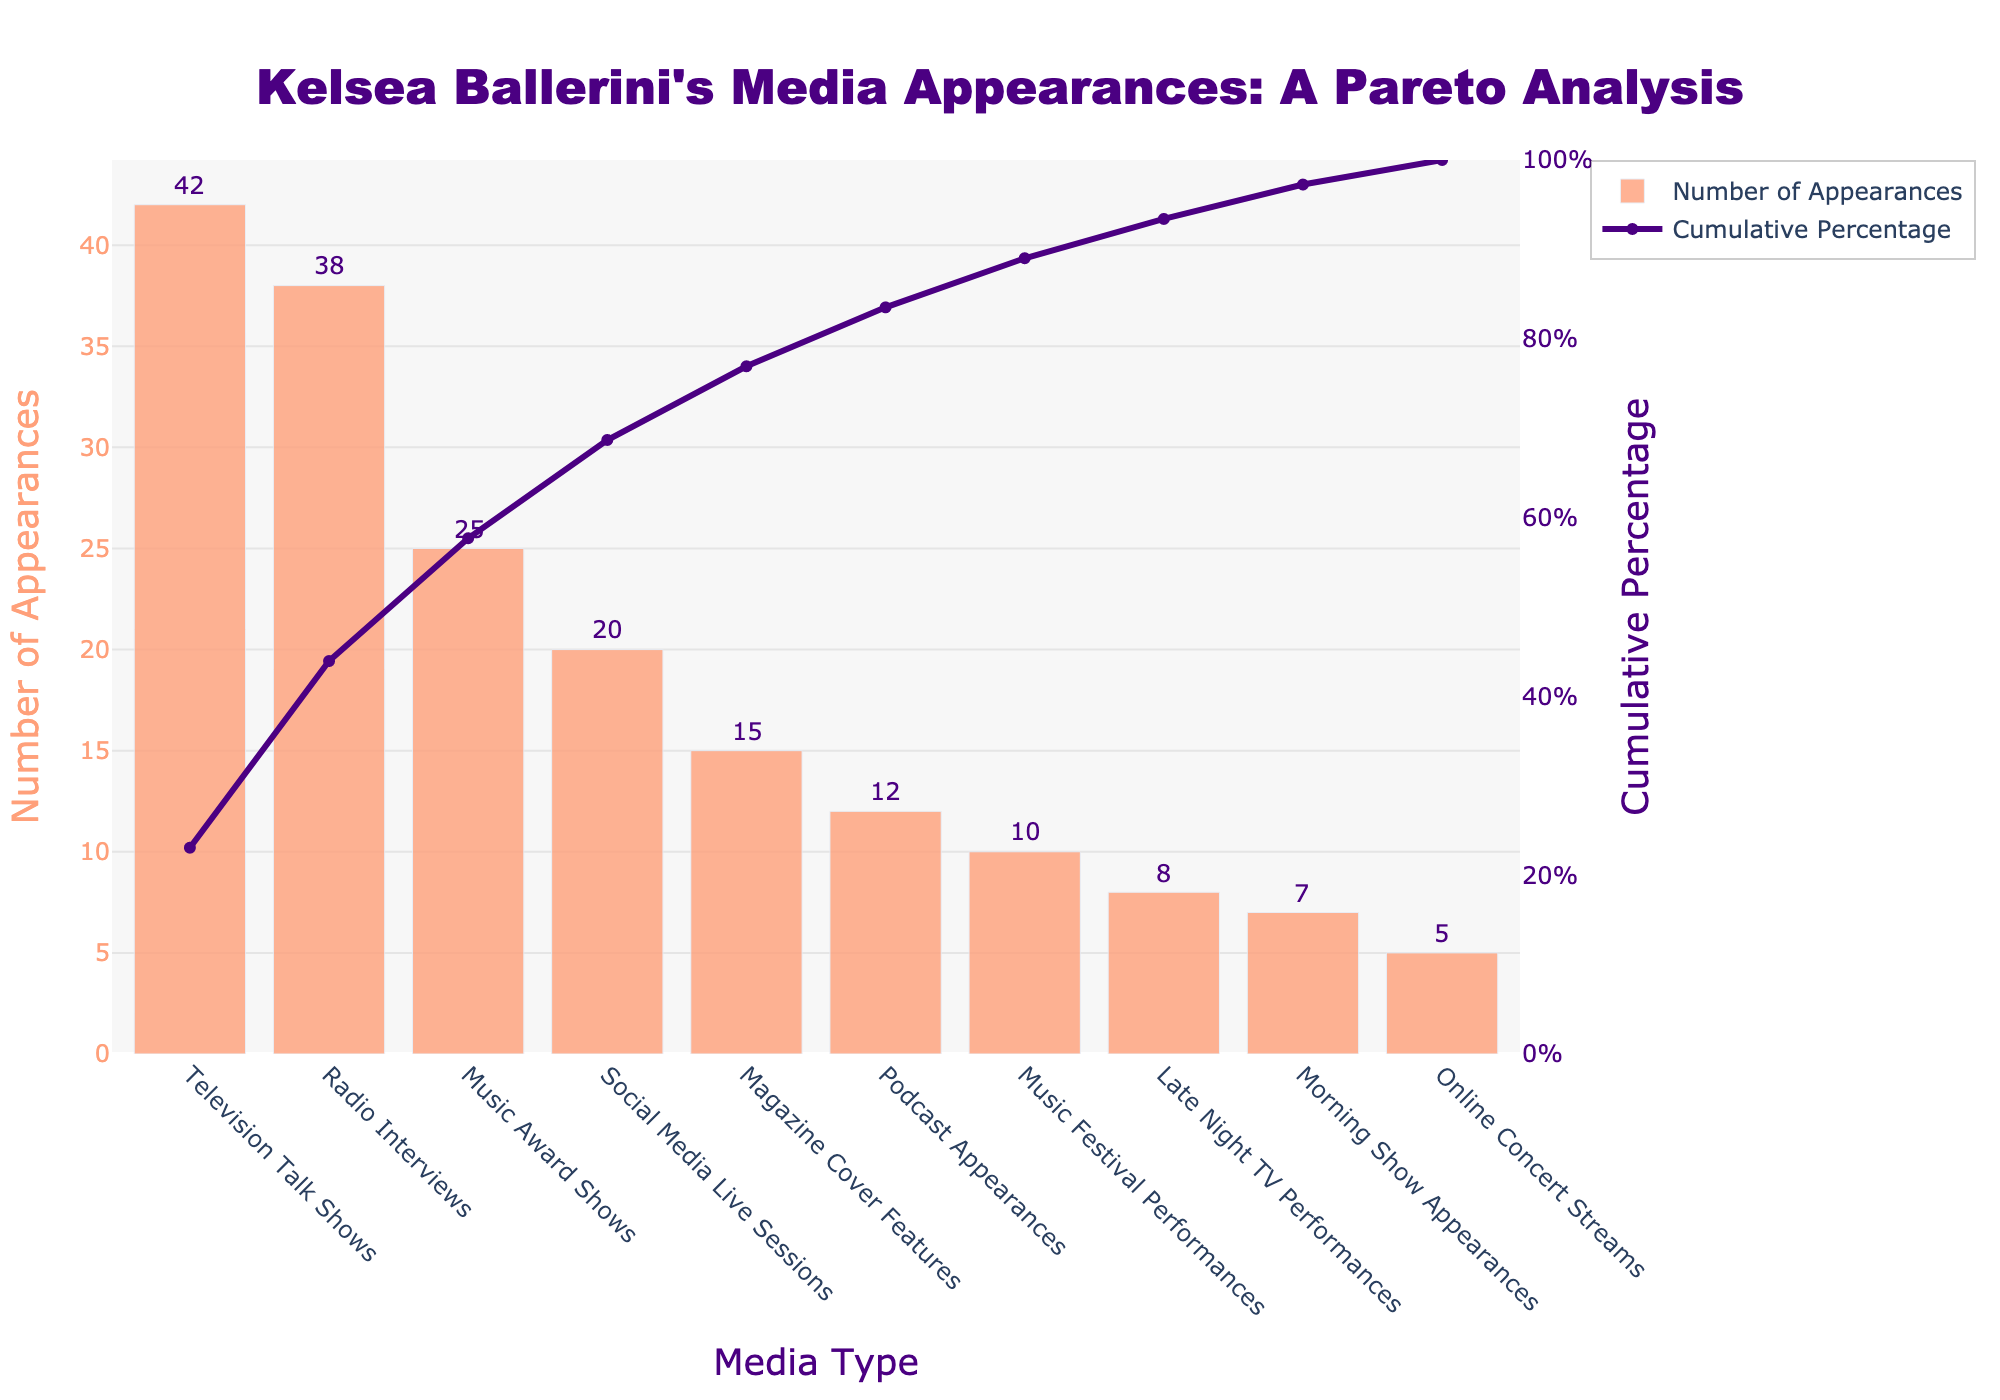How many types of media does Kelsea Ballerini use for her promotions? The x-axis of the figure lists the different media types used by Kelsea Ballerini for her promotions. Counting these types will give the total number.
Answer: 10 Which media type has the highest number of appearances? By observing the highest bar on the chart and reading the label on the x-axis, you determine the media type with the most appearances.
Answer: Television Talk Shows What is the total number of appearances made by Kelsea Ballerini across all media types? To find the sum of appearances for all media, add the number of appearances for each type. The numbers in the chart are: 42 (Television Talk Shows) + 38 (Radio Interviews) + 25 (Music Award Shows) + 20 (Social Media Live Sessions) + 15 (Magazine Cover Features) + 12 (Podcasts Appearances) + 10 (Music Festival Performances) + 8 (Late Night TV Performances) + 7 (Morning Show Appearances) + 5 (Online Concert Streams). Adding these: 42 + 38 + 25 + 20 + 15 + 12 + 10 + 8 + 7 + 5 = 182
Answer: 182 What percentage of total appearances do Television Talk Shows and Radio Interviews account for? First, add the number of appearances for the top two media types: 42 + 38 = 80. To find the percentage, divide by the total number of appearances and multiply by 100: (80 / 182) * 100 ≈ 43.96%.
Answer: ~43.96% At which cumulative percentage does the top three media types together reach? The cumulation of the first three media types from the top of the y-axis is 42 (Television Talk Shows) + 38 (Radio Interviews) + 25 (Music Award Shows) = 105. Next, calculate the cumulative percentage by (105 / 182) * 100 ≈ 57.69%.
Answer: ~57.69% Which media types have the least number of appearances, and what is their combined count? Observe the shortest bars from the chart, identifying the media types 'Online Concert Streams' and 'Morning Show Appearances' with 5 and 7 appearances respectively. Their combined count is 5 + 7 = 12
Answer: 12 What is the difference in the number of appearances between Music Festival Performances and Magazine Cover Features? Observing the bars corresponding to these media types on the chart, Magazine Cover Features has 15 appearances and Music Festival Performances has 10. The difference is 15 - 10 = 5
Answer: 5 Which media type marks the point when cumulative percentage crosses 90%? By following the cumulatively increasing line and reading against the x-axis at the point where the cumulative percentage exceeds 90%, identify the media type.
Answer: Podcast Appearances How many more appearances do Magazine Cover Features have over Podcasts Appearances? Subtract the number of Podcast Appearances (12) from Magazine Cover Features (15) resulting in 15 - 12 = 3
Answer: 3 